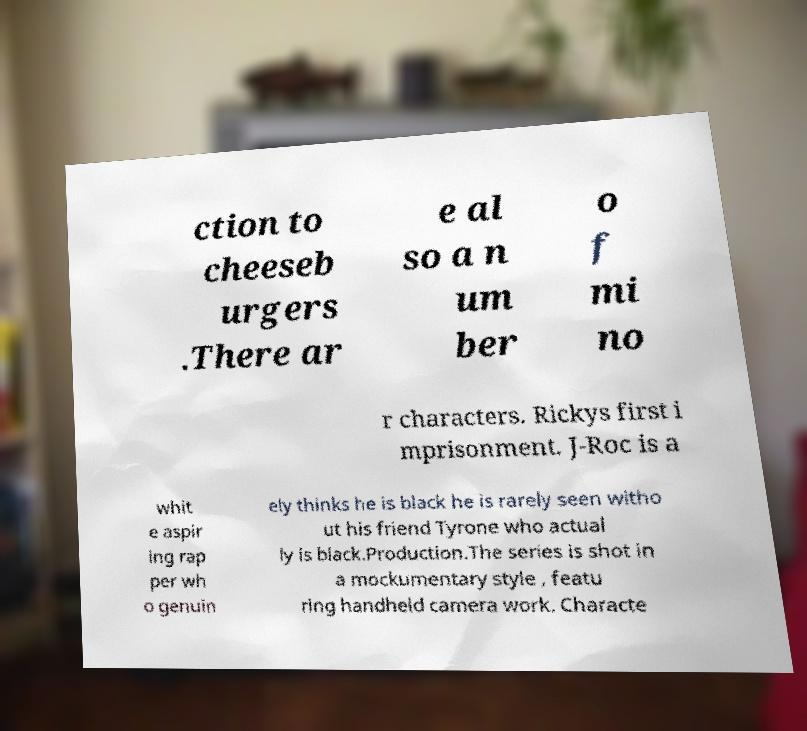For documentation purposes, I need the text within this image transcribed. Could you provide that? ction to cheeseb urgers .There ar e al so a n um ber o f mi no r characters. Rickys first i mprisonment. J-Roc is a whit e aspir ing rap per wh o genuin ely thinks he is black he is rarely seen witho ut his friend Tyrone who actual ly is black.Production.The series is shot in a mockumentary style , featu ring handheld camera work. Characte 